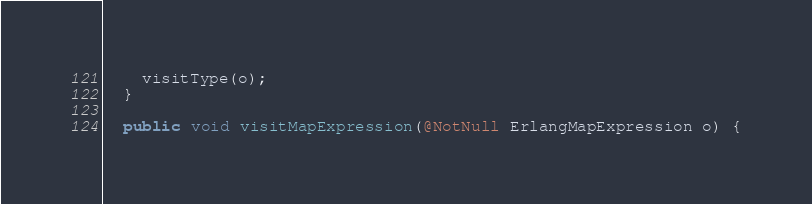Convert code to text. <code><loc_0><loc_0><loc_500><loc_500><_Java_>    visitType(o);
  }

  public void visitMapExpression(@NotNull ErlangMapExpression o) {</code> 